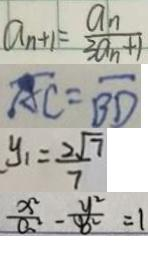<formula> <loc_0><loc_0><loc_500><loc_500>a _ { n + 1 } = \frac { a _ { n } } { 3 a _ { n } + 1 } 
 \overline { A C } = \overline { B D } 
 y _ { 1 } = \frac { 2 \sqrt { 7 } } { 7 } 
 \frac { x ^ { 2 } } { a ^ { 2 } } - \frac { y ^ { 2 } } { b ^ { 2 } } = 1</formula> 